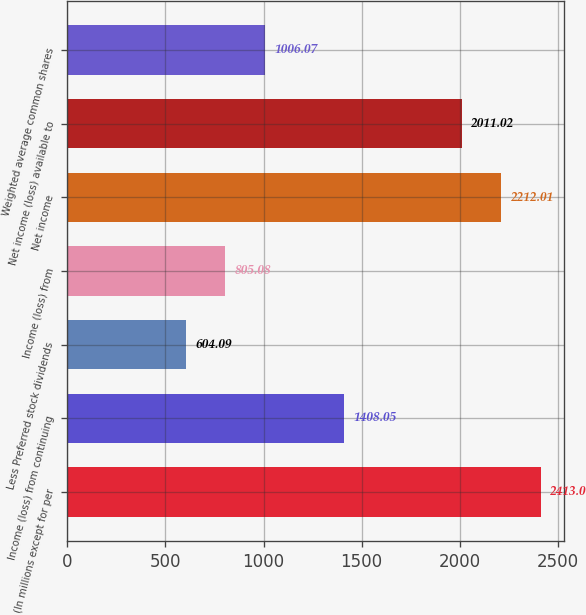Convert chart to OTSL. <chart><loc_0><loc_0><loc_500><loc_500><bar_chart><fcel>(In millions except for per<fcel>Income (loss) from continuing<fcel>Less Preferred stock dividends<fcel>Income (loss) from<fcel>Net income<fcel>Net income (loss) available to<fcel>Weighted average common shares<nl><fcel>2413<fcel>1408.05<fcel>604.09<fcel>805.08<fcel>2212.01<fcel>2011.02<fcel>1006.07<nl></chart> 